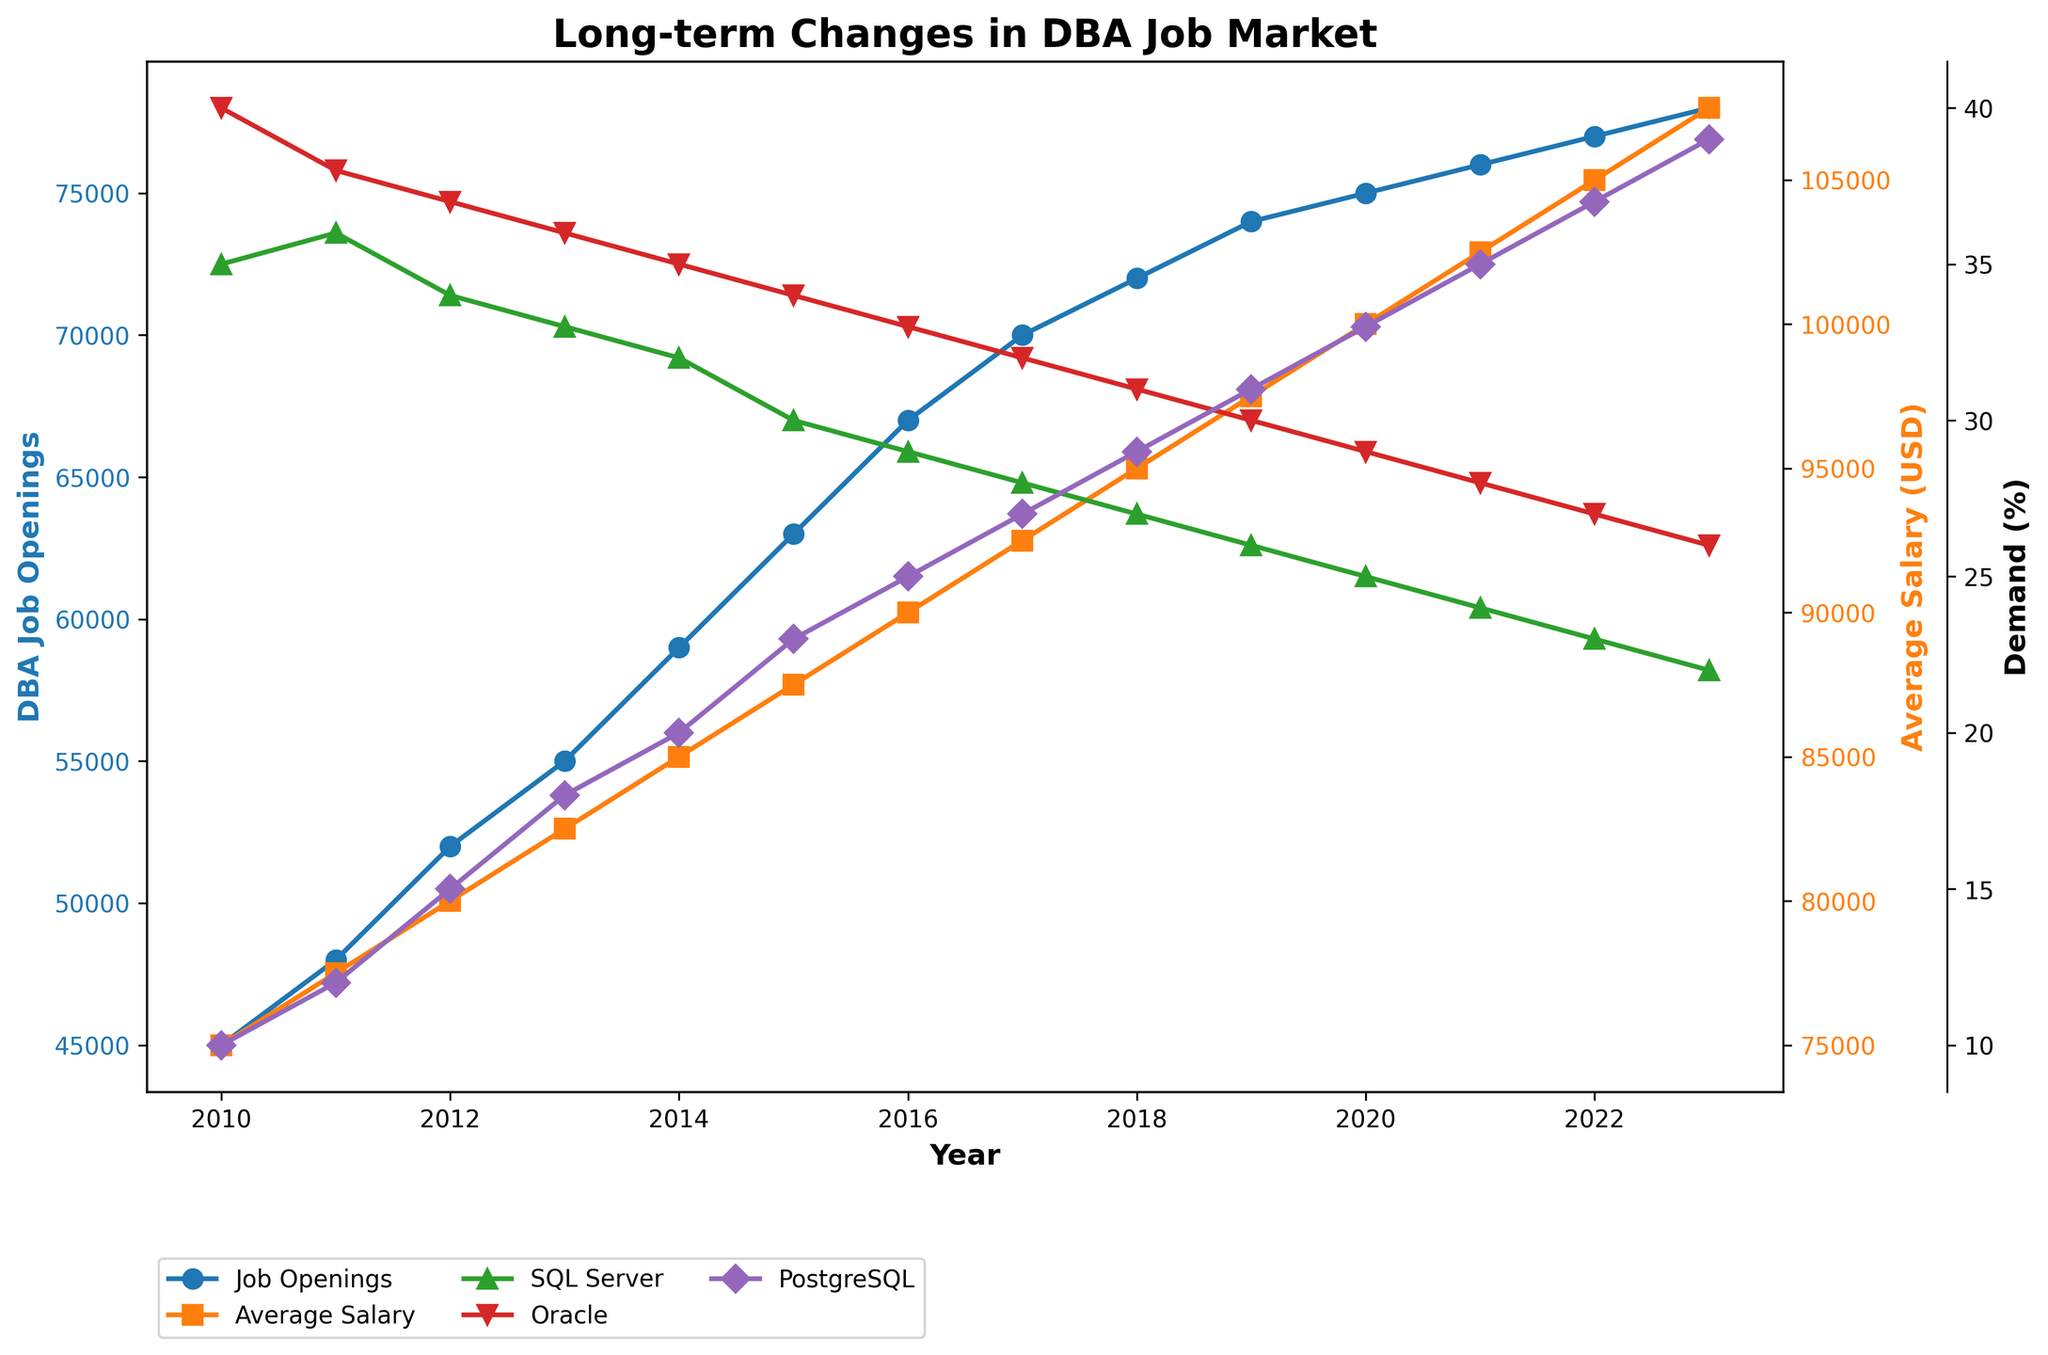What year had the highest number of DBA job openings? The highest point on the blue line representing "Job Openings" occurs at 2023.
Answer: 2023 How much did the average salary increase from 2010 to 2023? The average salary in 2010 was $75,000, and in 2023 it was $107,500. The increase is $107,500 - $75,000 = $32,500.
Answer: $32,500 Which database had the highest demand percentage in 2023? The purple line representing "PostgreSQL Demand" is the highest at 2023.
Answer: PostgreSQL Between which two consecutive years did DBA job openings increase the most? The steepest increase on the blue line representing "Job Openings" is between 2015 and 2016, going from 63,000 to 67,000, an increase of 4,000.
Answer: 2015 and 2016 In 2018, what is the difference in demand percentage between Oracle and PostgreSQL? The green line (Oracle Demand) is at 31% and the purple line (PostgreSQL Demand) is at 29% in 2018. The difference is 31% - 29% = 2%.
Answer: 2% Which year marks the start of a consistent decrease in SQL Server demand? The highest point of the green line representing "SQL Server Demand" is in 2011, after which it consistently decreases.
Answer: 2011 Comparing 2010 and 2020, how did the demand percentages for SQL Server and PostgreSQL change? In 2010, SQL Server demand was 35% and PostgreSQL demand was 10%. In 2020, SQL Server demand was 25% and PostgreSQL demand was 33%. SQL Server demand decreased by 10% while PostgreSQL demand increased by 23%.
Answer: SQL Server -10%, PostgreSQL +23% What was the average DBA job openings over the period from 2010 to 2013? Adding the job openings for 2010, 2011, 2012, and 2013 (45,000 + 48,000 + 52,000 + 55,000) and then dividing by 4 gives (200,000 / 4) = 50,000.
Answer: 50,000 By how much did the average salary increase each year, on average, between 2010 and 2023? The total increase in average salary from 2010 to 2023 is $32,500. There are 13 years between 2010 and 2023. Therefore, the average annual increase is $32,500 / 13 ≈ $2,500.
Answer: $2,500 What trend is observed for Oracle demand from 2010 to 2023? The red line representing "Oracle Demand" shows a consistent decrease from 40% in 2010 to 26% in 2023.
Answer: Decreasing 